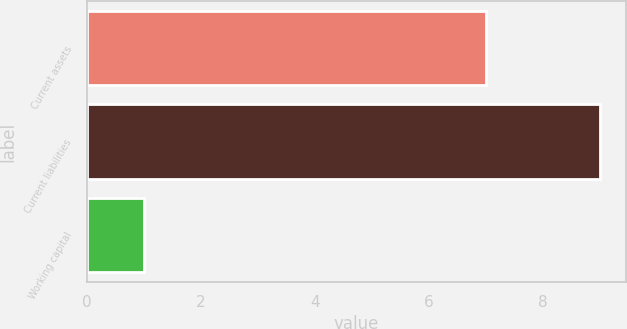<chart> <loc_0><loc_0><loc_500><loc_500><bar_chart><fcel>Current assets<fcel>Current liabilities<fcel>Working capital<nl><fcel>7<fcel>9<fcel>1<nl></chart> 